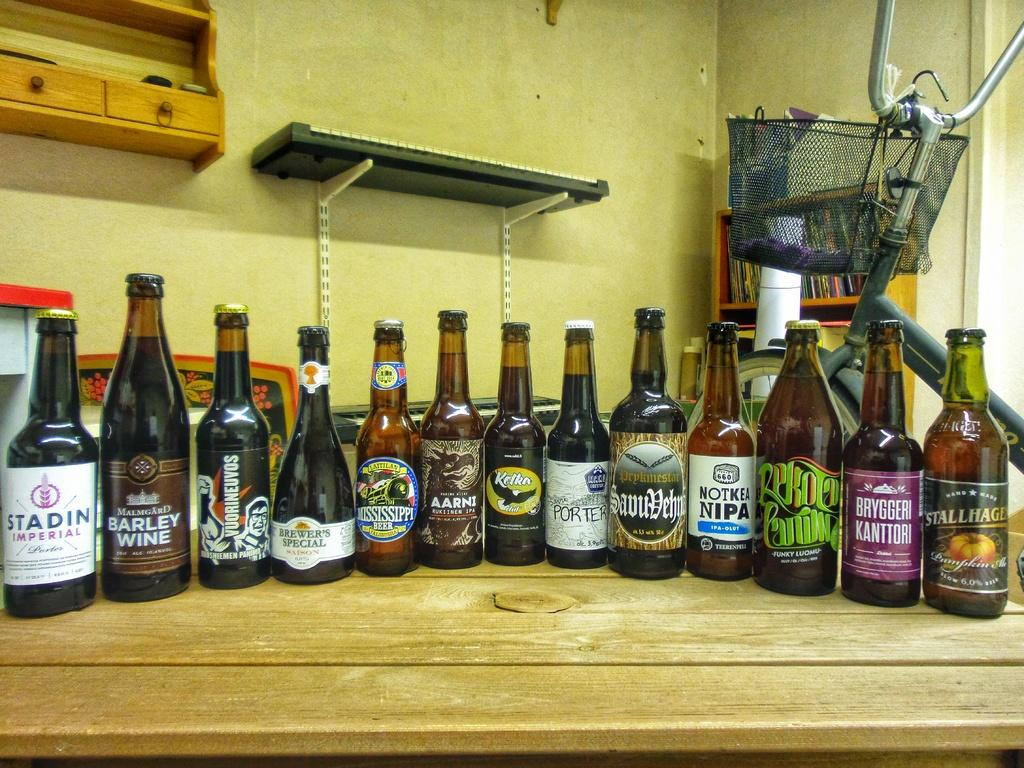Provide a one-sentence caption for the provided image. A bottle of Stadin Imperial is in line with several other bottles on a wooden surface. 